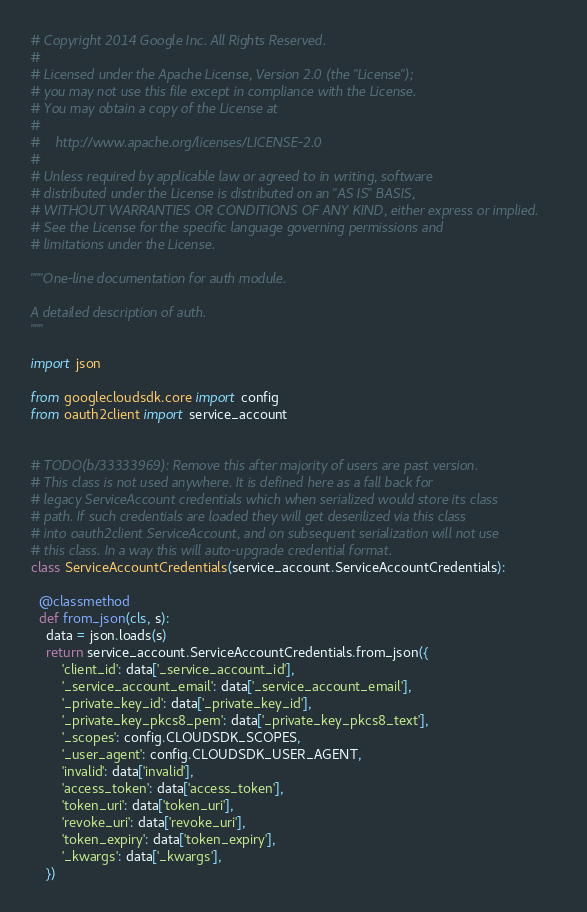<code> <loc_0><loc_0><loc_500><loc_500><_Python_># Copyright 2014 Google Inc. All Rights Reserved.
#
# Licensed under the Apache License, Version 2.0 (the "License");
# you may not use this file except in compliance with the License.
# You may obtain a copy of the License at
#
#    http://www.apache.org/licenses/LICENSE-2.0
#
# Unless required by applicable law or agreed to in writing, software
# distributed under the License is distributed on an "AS IS" BASIS,
# WITHOUT WARRANTIES OR CONDITIONS OF ANY KIND, either express or implied.
# See the License for the specific language governing permissions and
# limitations under the License.

"""One-line documentation for auth module.

A detailed description of auth.
"""

import json

from googlecloudsdk.core import config
from oauth2client import service_account


# TODO(b/33333969): Remove this after majority of users are past version.
# This class is not used anywhere. It is defined here as a fall back for
# legacy ServiceAccount credentials which when serialized would store its class
# path. If such credentials are loaded they will get deserilized via this class
# into oauth2client ServiceAccount, and on subsequent serialization will not use
# this class. In a way this will auto-upgrade credential format.
class ServiceAccountCredentials(service_account.ServiceAccountCredentials):

  @classmethod
  def from_json(cls, s):
    data = json.loads(s)
    return service_account.ServiceAccountCredentials.from_json({
        'client_id': data['_service_account_id'],
        '_service_account_email': data['_service_account_email'],
        '_private_key_id': data['_private_key_id'],
        '_private_key_pkcs8_pem': data['_private_key_pkcs8_text'],
        '_scopes': config.CLOUDSDK_SCOPES,
        '_user_agent': config.CLOUDSDK_USER_AGENT,
        'invalid': data['invalid'],
        'access_token': data['access_token'],
        'token_uri': data['token_uri'],
        'revoke_uri': data['revoke_uri'],
        'token_expiry': data['token_expiry'],
        '_kwargs': data['_kwargs'],
    })
</code> 